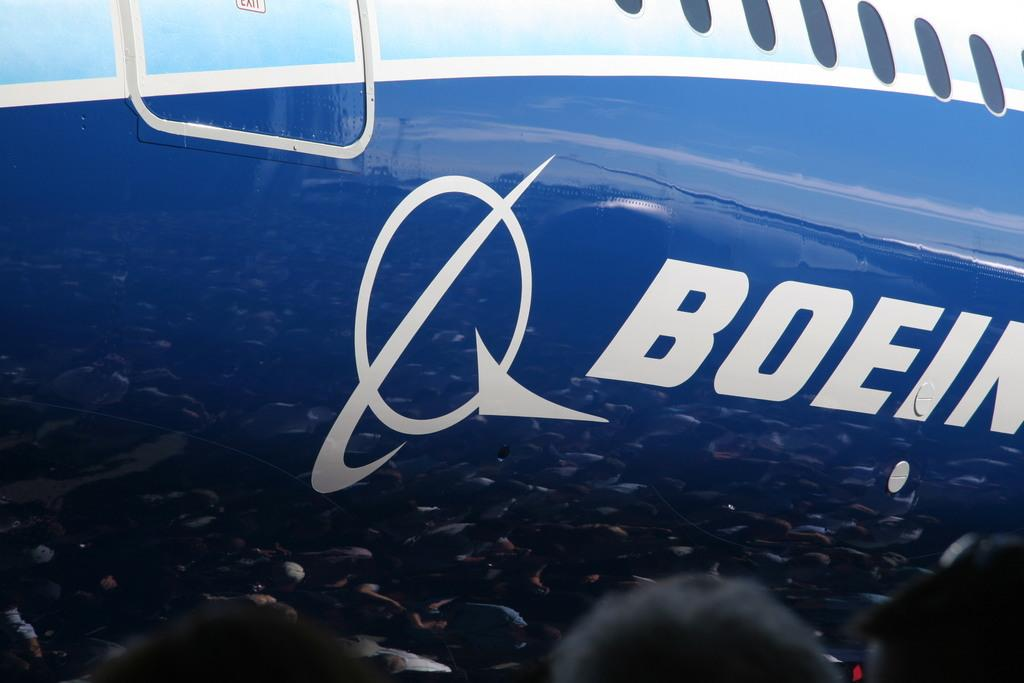<image>
Render a clear and concise summary of the photo. A blue, white and light blue plane with the words Boein and an emblem on the side. 